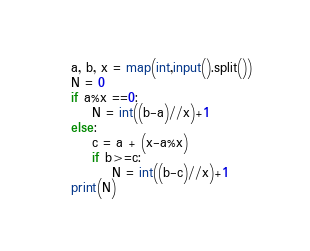<code> <loc_0><loc_0><loc_500><loc_500><_Python_>a, b, x = map(int,input().split())
N = 0
if a%x ==0:
    N = int((b-a)//x)+1
else:
    c = a + (x-a%x)
    if b>=c:
        N = int((b-c)//x)+1
print(N)</code> 